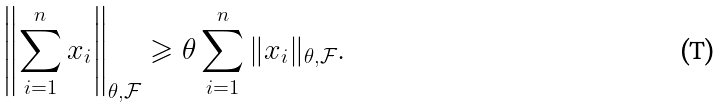<formula> <loc_0><loc_0><loc_500><loc_500>\left \| \sum _ { i = 1 } ^ { n } x _ { i } \right \| _ { \theta , \mathcal { F } } \geqslant \theta \sum _ { i = 1 } ^ { n } \| x _ { i } \| _ { \theta , \mathcal { F } } .</formula> 